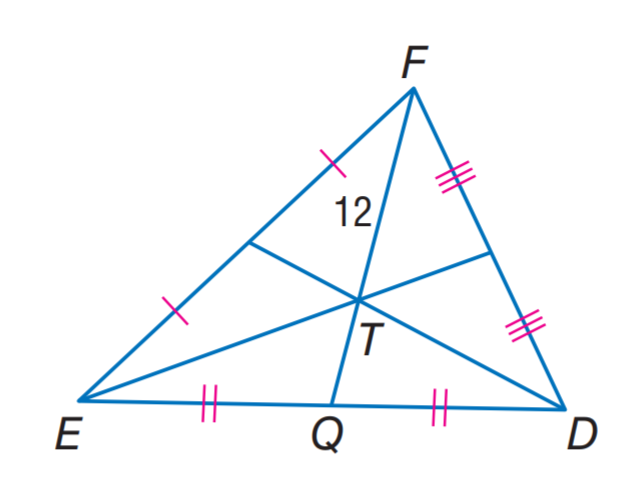Question: In \triangle E D F, T is the centroid and F T = 12. Find T Q.
Choices:
A. 3
B. 6
C. 12
D. 24
Answer with the letter. Answer: B 